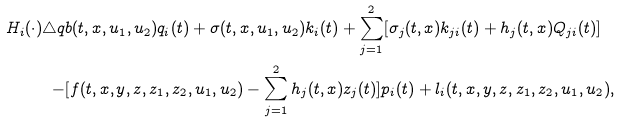Convert formula to latex. <formula><loc_0><loc_0><loc_500><loc_500>H _ { i } ( \cdot ) \triangle q & b ( t , x , u _ { 1 } , u _ { 2 } ) q _ { i } ( t ) + \sigma ( t , x , u _ { 1 } , u _ { 2 } ) k _ { i } ( t ) + \sum _ { j = 1 } ^ { 2 } [ \sigma _ { j } ( t , x ) k _ { j i } ( t ) + h _ { j } ( t , x ) Q _ { j i } ( t ) ] \\ - & [ f ( t , x , y , z , z _ { 1 } , z _ { 2 } , u _ { 1 } , u _ { 2 } ) - \sum _ { j = 1 } ^ { 2 } h _ { j } ( t , x ) z _ { j } ( t ) ] p _ { i } ( t ) + l _ { i } ( t , x , y , z , z _ { 1 } , z _ { 2 } , u _ { 1 } , u _ { 2 } ) , \\</formula> 